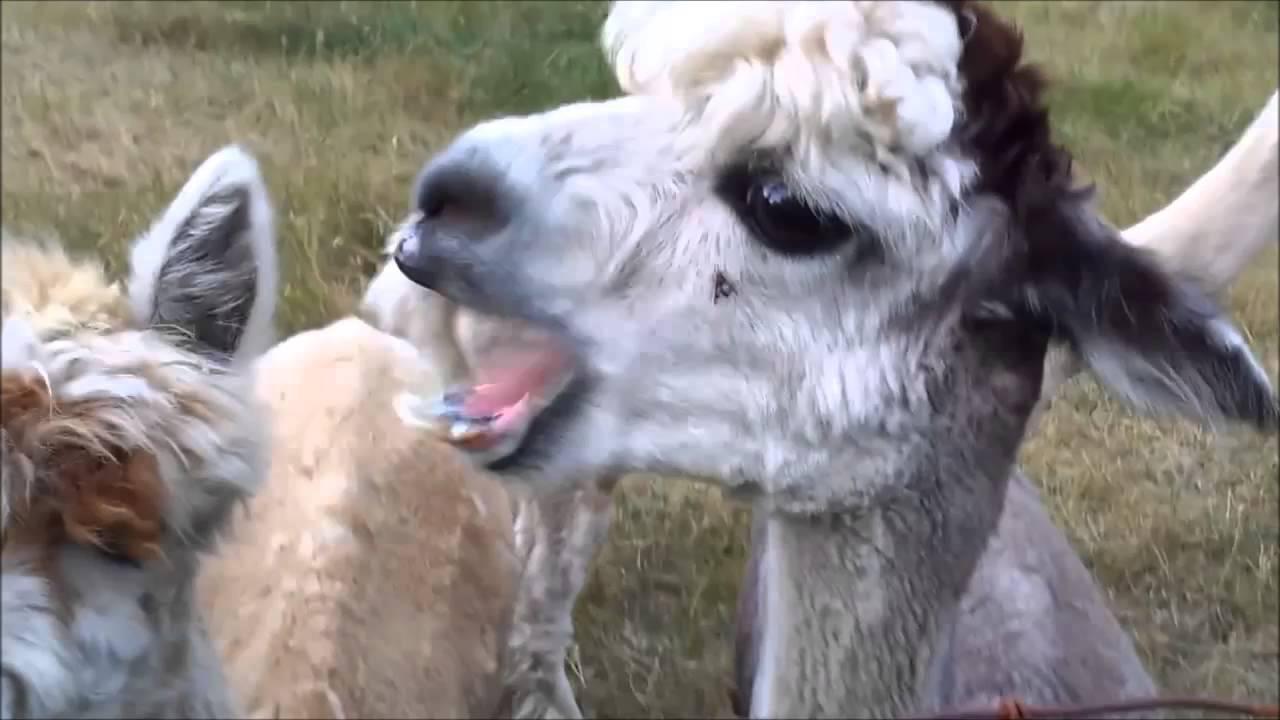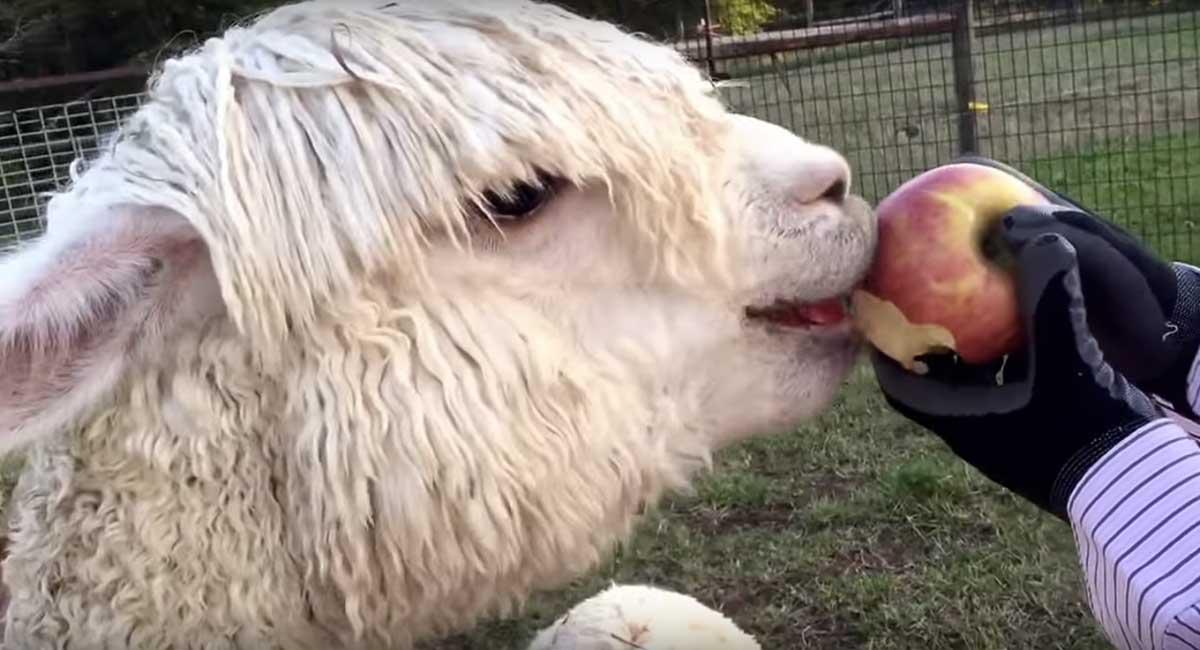The first image is the image on the left, the second image is the image on the right. Considering the images on both sides, is "A llama is being fed an apple." valid? Answer yes or no. Yes. The first image is the image on the left, the second image is the image on the right. Assess this claim about the two images: "In the right image, a pair of black-gloved hands are offering an apple to a white llama that is facing rightward.". Correct or not? Answer yes or no. Yes. 